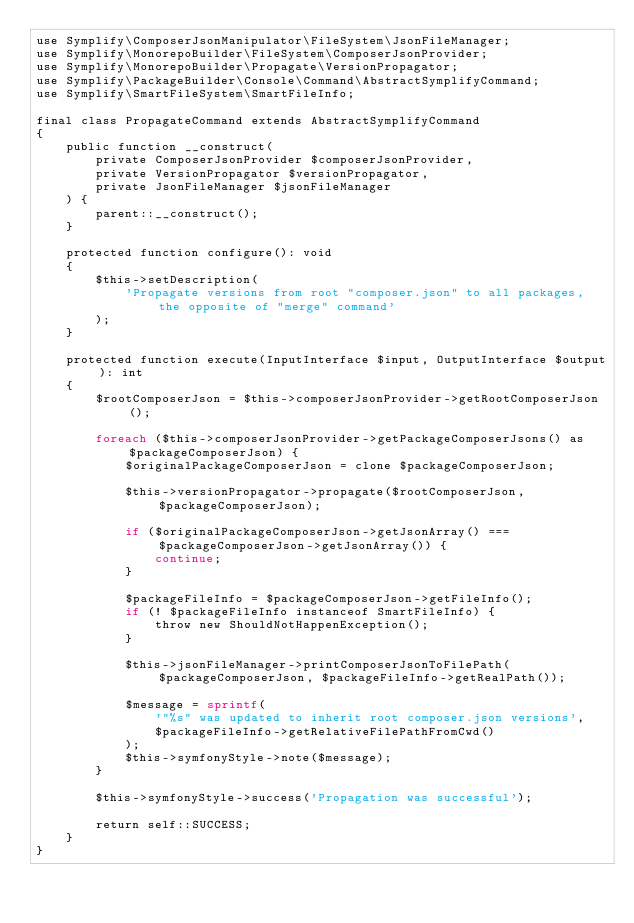<code> <loc_0><loc_0><loc_500><loc_500><_PHP_>use Symplify\ComposerJsonManipulator\FileSystem\JsonFileManager;
use Symplify\MonorepoBuilder\FileSystem\ComposerJsonProvider;
use Symplify\MonorepoBuilder\Propagate\VersionPropagator;
use Symplify\PackageBuilder\Console\Command\AbstractSymplifyCommand;
use Symplify\SmartFileSystem\SmartFileInfo;

final class PropagateCommand extends AbstractSymplifyCommand
{
    public function __construct(
        private ComposerJsonProvider $composerJsonProvider,
        private VersionPropagator $versionPropagator,
        private JsonFileManager $jsonFileManager
    ) {
        parent::__construct();
    }

    protected function configure(): void
    {
        $this->setDescription(
            'Propagate versions from root "composer.json" to all packages, the opposite of "merge" command'
        );
    }

    protected function execute(InputInterface $input, OutputInterface $output): int
    {
        $rootComposerJson = $this->composerJsonProvider->getRootComposerJson();

        foreach ($this->composerJsonProvider->getPackageComposerJsons() as $packageComposerJson) {
            $originalPackageComposerJson = clone $packageComposerJson;

            $this->versionPropagator->propagate($rootComposerJson, $packageComposerJson);

            if ($originalPackageComposerJson->getJsonArray() === $packageComposerJson->getJsonArray()) {
                continue;
            }

            $packageFileInfo = $packageComposerJson->getFileInfo();
            if (! $packageFileInfo instanceof SmartFileInfo) {
                throw new ShouldNotHappenException();
            }

            $this->jsonFileManager->printComposerJsonToFilePath($packageComposerJson, $packageFileInfo->getRealPath());

            $message = sprintf(
                '"%s" was updated to inherit root composer.json versions',
                $packageFileInfo->getRelativeFilePathFromCwd()
            );
            $this->symfonyStyle->note($message);
        }

        $this->symfonyStyle->success('Propagation was successful');

        return self::SUCCESS;
    }
}
</code> 